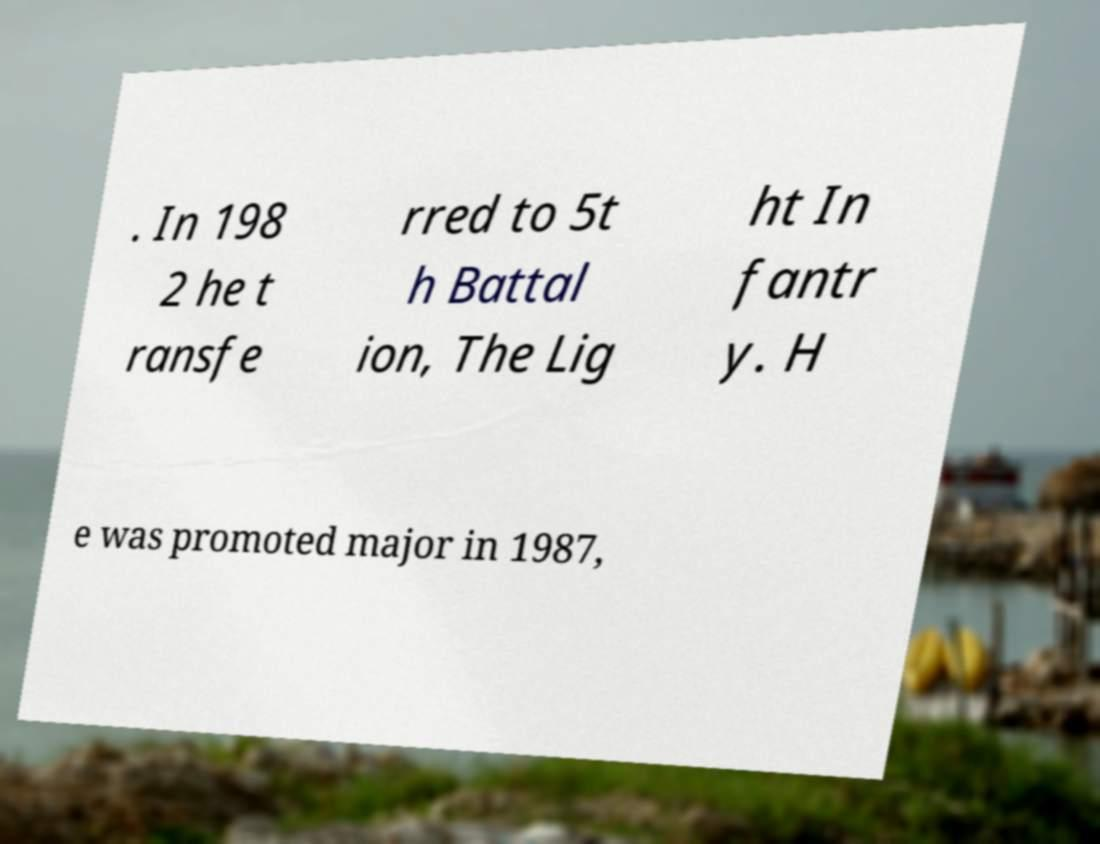Can you read and provide the text displayed in the image?This photo seems to have some interesting text. Can you extract and type it out for me? . In 198 2 he t ransfe rred to 5t h Battal ion, The Lig ht In fantr y. H e was promoted major in 1987, 